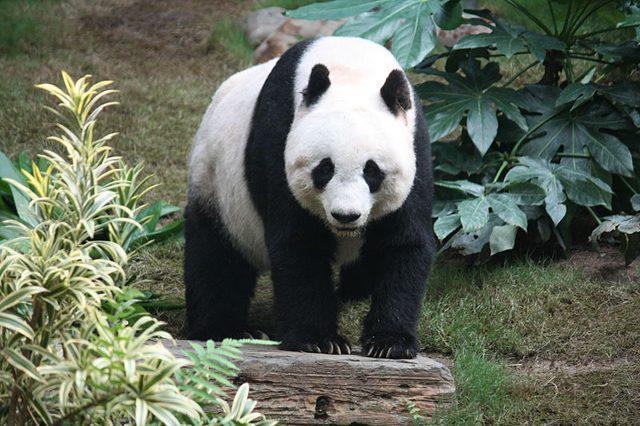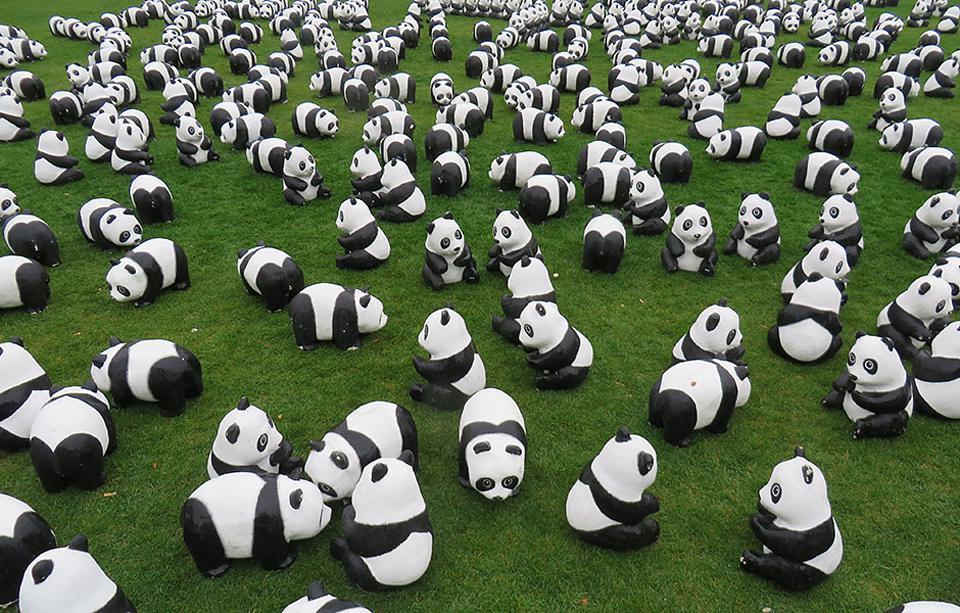The first image is the image on the left, the second image is the image on the right. Assess this claim about the two images: "Each image contains only one panda, and one image shows a panda with its paws draped over something for support.". Correct or not? Answer yes or no. No. The first image is the image on the left, the second image is the image on the right. Evaluate the accuracy of this statement regarding the images: "There is at least one panda up in a tree.". Is it true? Answer yes or no. No. 